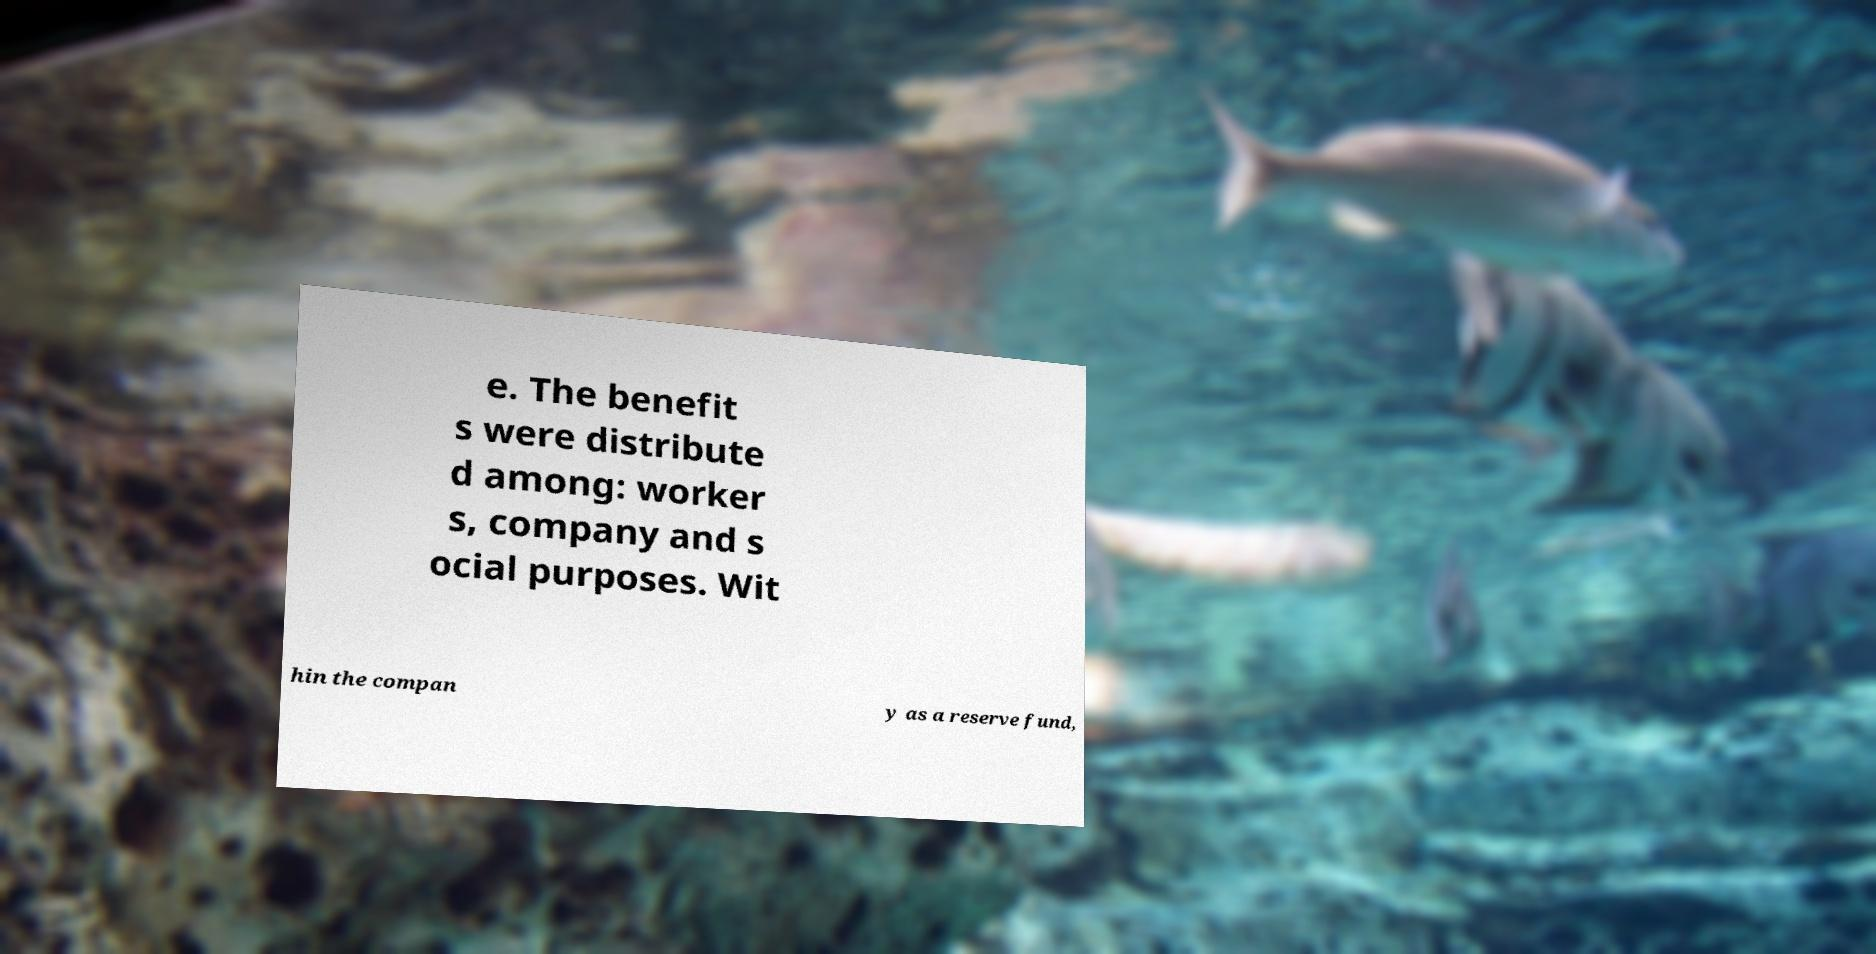I need the written content from this picture converted into text. Can you do that? e. The benefit s were distribute d among: worker s, company and s ocial purposes. Wit hin the compan y as a reserve fund, 